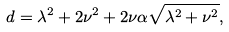<formula> <loc_0><loc_0><loc_500><loc_500>d = \lambda ^ { 2 } + 2 \nu ^ { 2 } + 2 \nu \alpha \sqrt { \lambda ^ { 2 } + \nu ^ { 2 } } ,</formula> 